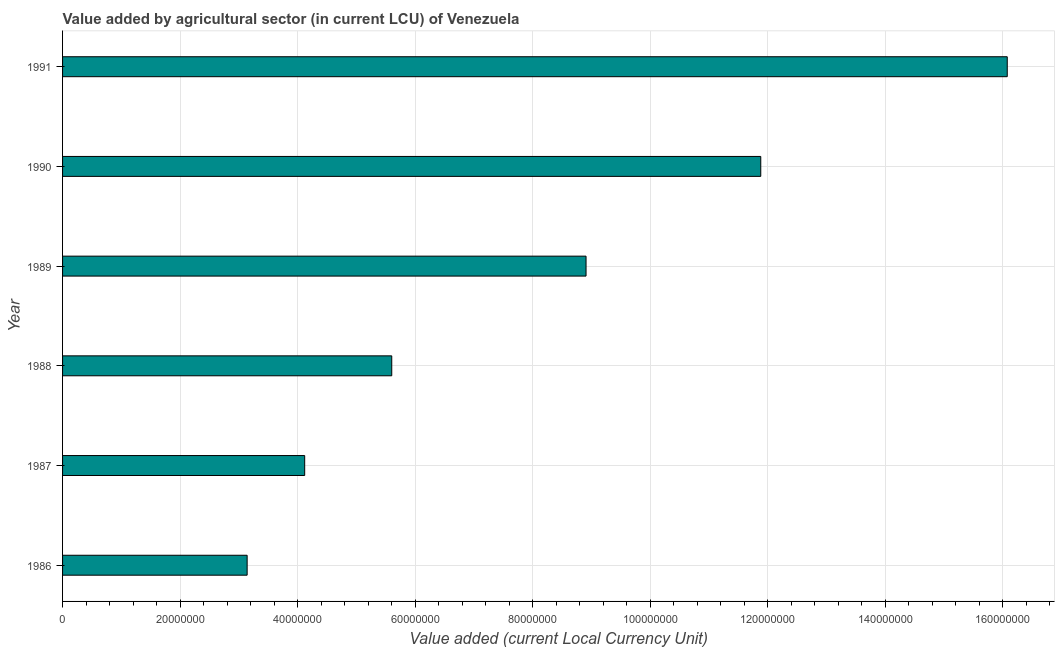Does the graph contain any zero values?
Offer a terse response. No. Does the graph contain grids?
Provide a succinct answer. Yes. What is the title of the graph?
Give a very brief answer. Value added by agricultural sector (in current LCU) of Venezuela. What is the label or title of the X-axis?
Your answer should be compact. Value added (current Local Currency Unit). What is the value added by agriculture sector in 1986?
Give a very brief answer. 3.14e+07. Across all years, what is the maximum value added by agriculture sector?
Offer a terse response. 1.61e+08. Across all years, what is the minimum value added by agriculture sector?
Ensure brevity in your answer.  3.14e+07. What is the sum of the value added by agriculture sector?
Provide a short and direct response. 4.97e+08. What is the difference between the value added by agriculture sector in 1989 and 1991?
Ensure brevity in your answer.  -7.17e+07. What is the average value added by agriculture sector per year?
Your answer should be compact. 8.29e+07. What is the median value added by agriculture sector?
Offer a terse response. 7.25e+07. In how many years, is the value added by agriculture sector greater than 164000000 LCU?
Offer a very short reply. 0. What is the ratio of the value added by agriculture sector in 1986 to that in 1991?
Your answer should be compact. 0.2. Is the value added by agriculture sector in 1986 less than that in 1990?
Your answer should be compact. Yes. What is the difference between the highest and the second highest value added by agriculture sector?
Give a very brief answer. 4.19e+07. What is the difference between the highest and the lowest value added by agriculture sector?
Your response must be concise. 1.29e+08. How many bars are there?
Offer a terse response. 6. What is the difference between two consecutive major ticks on the X-axis?
Your answer should be very brief. 2.00e+07. What is the Value added (current Local Currency Unit) of 1986?
Keep it short and to the point. 3.14e+07. What is the Value added (current Local Currency Unit) of 1987?
Make the answer very short. 4.12e+07. What is the Value added (current Local Currency Unit) of 1988?
Give a very brief answer. 5.60e+07. What is the Value added (current Local Currency Unit) in 1989?
Your answer should be very brief. 8.91e+07. What is the Value added (current Local Currency Unit) of 1990?
Provide a succinct answer. 1.19e+08. What is the Value added (current Local Currency Unit) of 1991?
Make the answer very short. 1.61e+08. What is the difference between the Value added (current Local Currency Unit) in 1986 and 1987?
Provide a succinct answer. -9.79e+06. What is the difference between the Value added (current Local Currency Unit) in 1986 and 1988?
Your answer should be very brief. -2.46e+07. What is the difference between the Value added (current Local Currency Unit) in 1986 and 1989?
Offer a terse response. -5.77e+07. What is the difference between the Value added (current Local Currency Unit) in 1986 and 1990?
Give a very brief answer. -8.74e+07. What is the difference between the Value added (current Local Currency Unit) in 1986 and 1991?
Give a very brief answer. -1.29e+08. What is the difference between the Value added (current Local Currency Unit) in 1987 and 1988?
Ensure brevity in your answer.  -1.48e+07. What is the difference between the Value added (current Local Currency Unit) in 1987 and 1989?
Give a very brief answer. -4.79e+07. What is the difference between the Value added (current Local Currency Unit) in 1987 and 1990?
Provide a short and direct response. -7.76e+07. What is the difference between the Value added (current Local Currency Unit) in 1987 and 1991?
Keep it short and to the point. -1.20e+08. What is the difference between the Value added (current Local Currency Unit) in 1988 and 1989?
Offer a very short reply. -3.31e+07. What is the difference between the Value added (current Local Currency Unit) in 1988 and 1990?
Offer a very short reply. -6.28e+07. What is the difference between the Value added (current Local Currency Unit) in 1988 and 1991?
Keep it short and to the point. -1.05e+08. What is the difference between the Value added (current Local Currency Unit) in 1989 and 1990?
Offer a very short reply. -2.97e+07. What is the difference between the Value added (current Local Currency Unit) in 1989 and 1991?
Offer a terse response. -7.17e+07. What is the difference between the Value added (current Local Currency Unit) in 1990 and 1991?
Provide a short and direct response. -4.19e+07. What is the ratio of the Value added (current Local Currency Unit) in 1986 to that in 1987?
Your answer should be compact. 0.76. What is the ratio of the Value added (current Local Currency Unit) in 1986 to that in 1988?
Your answer should be compact. 0.56. What is the ratio of the Value added (current Local Currency Unit) in 1986 to that in 1989?
Keep it short and to the point. 0.35. What is the ratio of the Value added (current Local Currency Unit) in 1986 to that in 1990?
Provide a succinct answer. 0.26. What is the ratio of the Value added (current Local Currency Unit) in 1986 to that in 1991?
Your response must be concise. 0.2. What is the ratio of the Value added (current Local Currency Unit) in 1987 to that in 1988?
Your answer should be very brief. 0.74. What is the ratio of the Value added (current Local Currency Unit) in 1987 to that in 1989?
Ensure brevity in your answer.  0.46. What is the ratio of the Value added (current Local Currency Unit) in 1987 to that in 1990?
Your answer should be very brief. 0.35. What is the ratio of the Value added (current Local Currency Unit) in 1987 to that in 1991?
Your response must be concise. 0.26. What is the ratio of the Value added (current Local Currency Unit) in 1988 to that in 1989?
Provide a short and direct response. 0.63. What is the ratio of the Value added (current Local Currency Unit) in 1988 to that in 1990?
Keep it short and to the point. 0.47. What is the ratio of the Value added (current Local Currency Unit) in 1988 to that in 1991?
Offer a very short reply. 0.35. What is the ratio of the Value added (current Local Currency Unit) in 1989 to that in 1990?
Offer a very short reply. 0.75. What is the ratio of the Value added (current Local Currency Unit) in 1989 to that in 1991?
Keep it short and to the point. 0.55. What is the ratio of the Value added (current Local Currency Unit) in 1990 to that in 1991?
Offer a very short reply. 0.74. 